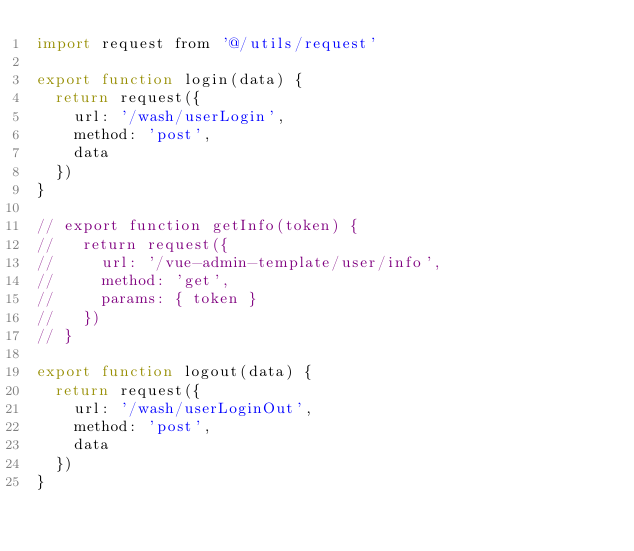Convert code to text. <code><loc_0><loc_0><loc_500><loc_500><_JavaScript_>import request from '@/utils/request'

export function login(data) {
  return request({
    url: '/wash/userLogin',
    method: 'post',
    data
  })
}

// export function getInfo(token) {
//   return request({
//     url: '/vue-admin-template/user/info',
//     method: 'get',
//     params: { token }
//   })
// }

export function logout(data) {
  return request({
    url: '/wash/userLoginOut',
    method: 'post',
    data
  })
}
</code> 